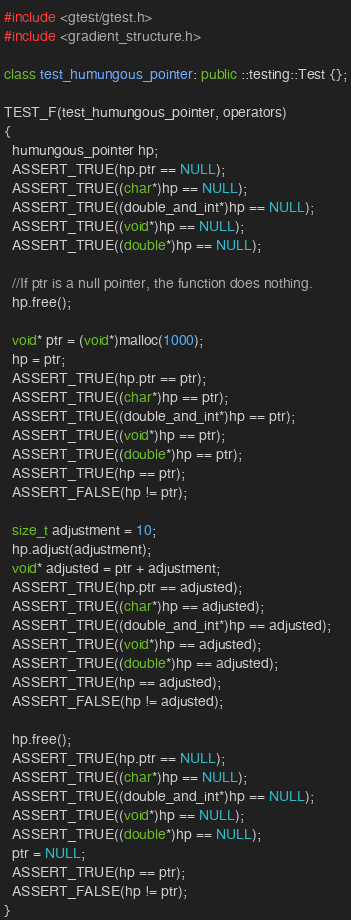Convert code to text. <code><loc_0><loc_0><loc_500><loc_500><_C++_>#include <gtest/gtest.h>
#include <gradient_structure.h>

class test_humungous_pointer: public ::testing::Test {};

TEST_F(test_humungous_pointer, operators)
{
  humungous_pointer hp;
  ASSERT_TRUE(hp.ptr == NULL);
  ASSERT_TRUE((char*)hp == NULL);
  ASSERT_TRUE((double_and_int*)hp == NULL);
  ASSERT_TRUE((void*)hp == NULL);
  ASSERT_TRUE((double*)hp == NULL);

  //If ptr is a null pointer, the function does nothing.
  hp.free();

  void* ptr = (void*)malloc(1000);
  hp = ptr;
  ASSERT_TRUE(hp.ptr == ptr);
  ASSERT_TRUE((char*)hp == ptr);
  ASSERT_TRUE((double_and_int*)hp == ptr);
  ASSERT_TRUE((void*)hp == ptr);
  ASSERT_TRUE((double*)hp == ptr);
  ASSERT_TRUE(hp == ptr);
  ASSERT_FALSE(hp != ptr);

  size_t adjustment = 10;
  hp.adjust(adjustment);
  void* adjusted = ptr + adjustment;
  ASSERT_TRUE(hp.ptr == adjusted);
  ASSERT_TRUE((char*)hp == adjusted);
  ASSERT_TRUE((double_and_int*)hp == adjusted);
  ASSERT_TRUE((void*)hp == adjusted);
  ASSERT_TRUE((double*)hp == adjusted);
  ASSERT_TRUE(hp == adjusted);
  ASSERT_FALSE(hp != adjusted);

  hp.free();
  ASSERT_TRUE(hp.ptr == NULL);
  ASSERT_TRUE((char*)hp == NULL);
  ASSERT_TRUE((double_and_int*)hp == NULL);
  ASSERT_TRUE((void*)hp == NULL);
  ASSERT_TRUE((double*)hp == NULL);
  ptr = NULL;
  ASSERT_TRUE(hp == ptr);
  ASSERT_FALSE(hp != ptr);
}
</code> 